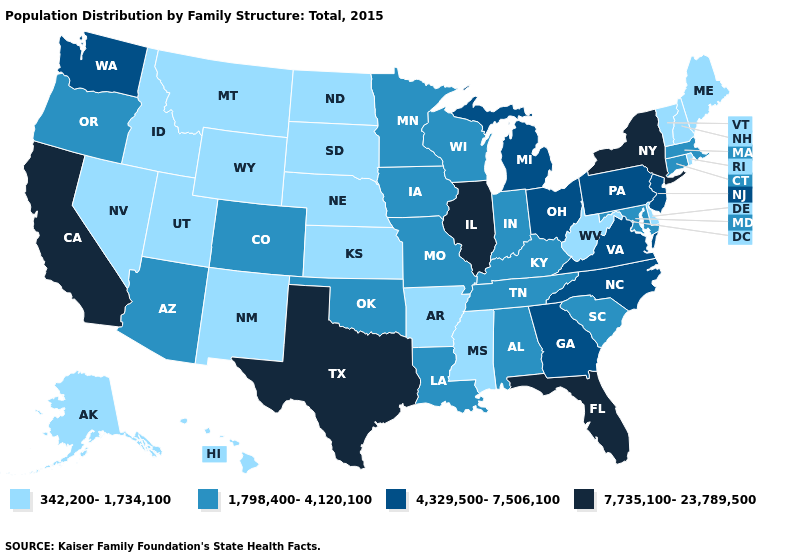Name the states that have a value in the range 342,200-1,734,100?
Give a very brief answer. Alaska, Arkansas, Delaware, Hawaii, Idaho, Kansas, Maine, Mississippi, Montana, Nebraska, Nevada, New Hampshire, New Mexico, North Dakota, Rhode Island, South Dakota, Utah, Vermont, West Virginia, Wyoming. Name the states that have a value in the range 4,329,500-7,506,100?
Concise answer only. Georgia, Michigan, New Jersey, North Carolina, Ohio, Pennsylvania, Virginia, Washington. Name the states that have a value in the range 4,329,500-7,506,100?
Give a very brief answer. Georgia, Michigan, New Jersey, North Carolina, Ohio, Pennsylvania, Virginia, Washington. Among the states that border Mississippi , which have the highest value?
Give a very brief answer. Alabama, Louisiana, Tennessee. How many symbols are there in the legend?
Keep it brief. 4. Does the first symbol in the legend represent the smallest category?
Keep it brief. Yes. Name the states that have a value in the range 7,735,100-23,789,500?
Give a very brief answer. California, Florida, Illinois, New York, Texas. Does the map have missing data?
Write a very short answer. No. Among the states that border California , which have the highest value?
Quick response, please. Arizona, Oregon. Which states have the lowest value in the USA?
Answer briefly. Alaska, Arkansas, Delaware, Hawaii, Idaho, Kansas, Maine, Mississippi, Montana, Nebraska, Nevada, New Hampshire, New Mexico, North Dakota, Rhode Island, South Dakota, Utah, Vermont, West Virginia, Wyoming. What is the value of North Dakota?
Give a very brief answer. 342,200-1,734,100. Which states have the highest value in the USA?
Answer briefly. California, Florida, Illinois, New York, Texas. Does New York have the highest value in the USA?
Short answer required. Yes. What is the highest value in states that border North Dakota?
Short answer required. 1,798,400-4,120,100. Name the states that have a value in the range 342,200-1,734,100?
Keep it brief. Alaska, Arkansas, Delaware, Hawaii, Idaho, Kansas, Maine, Mississippi, Montana, Nebraska, Nevada, New Hampshire, New Mexico, North Dakota, Rhode Island, South Dakota, Utah, Vermont, West Virginia, Wyoming. 